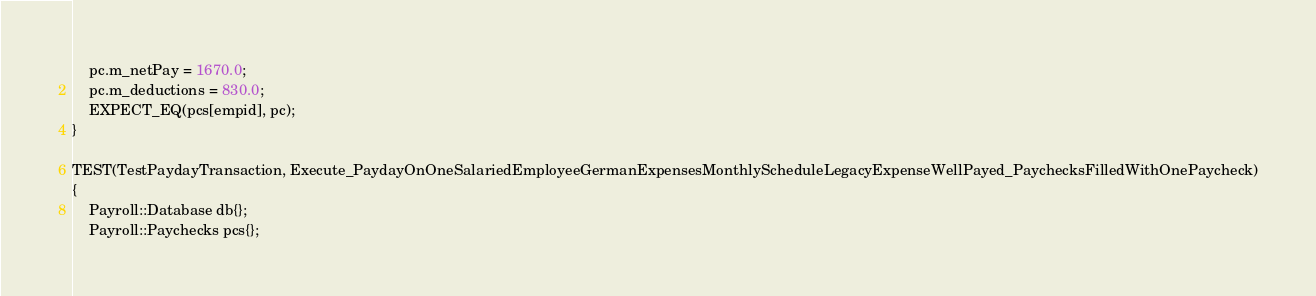<code> <loc_0><loc_0><loc_500><loc_500><_C++_>	pc.m_netPay = 1670.0;
	pc.m_deductions = 830.0;
	EXPECT_EQ(pcs[empid], pc);
}

TEST(TestPaydayTransaction, Execute_PaydayOnOneSalariedEmployeeGermanExpensesMonthlyScheduleLegacyExpenseWellPayed_PaychecksFilledWithOnePaycheck)
{
	Payroll::Database db{};
	Payroll::Paychecks pcs{};</code> 